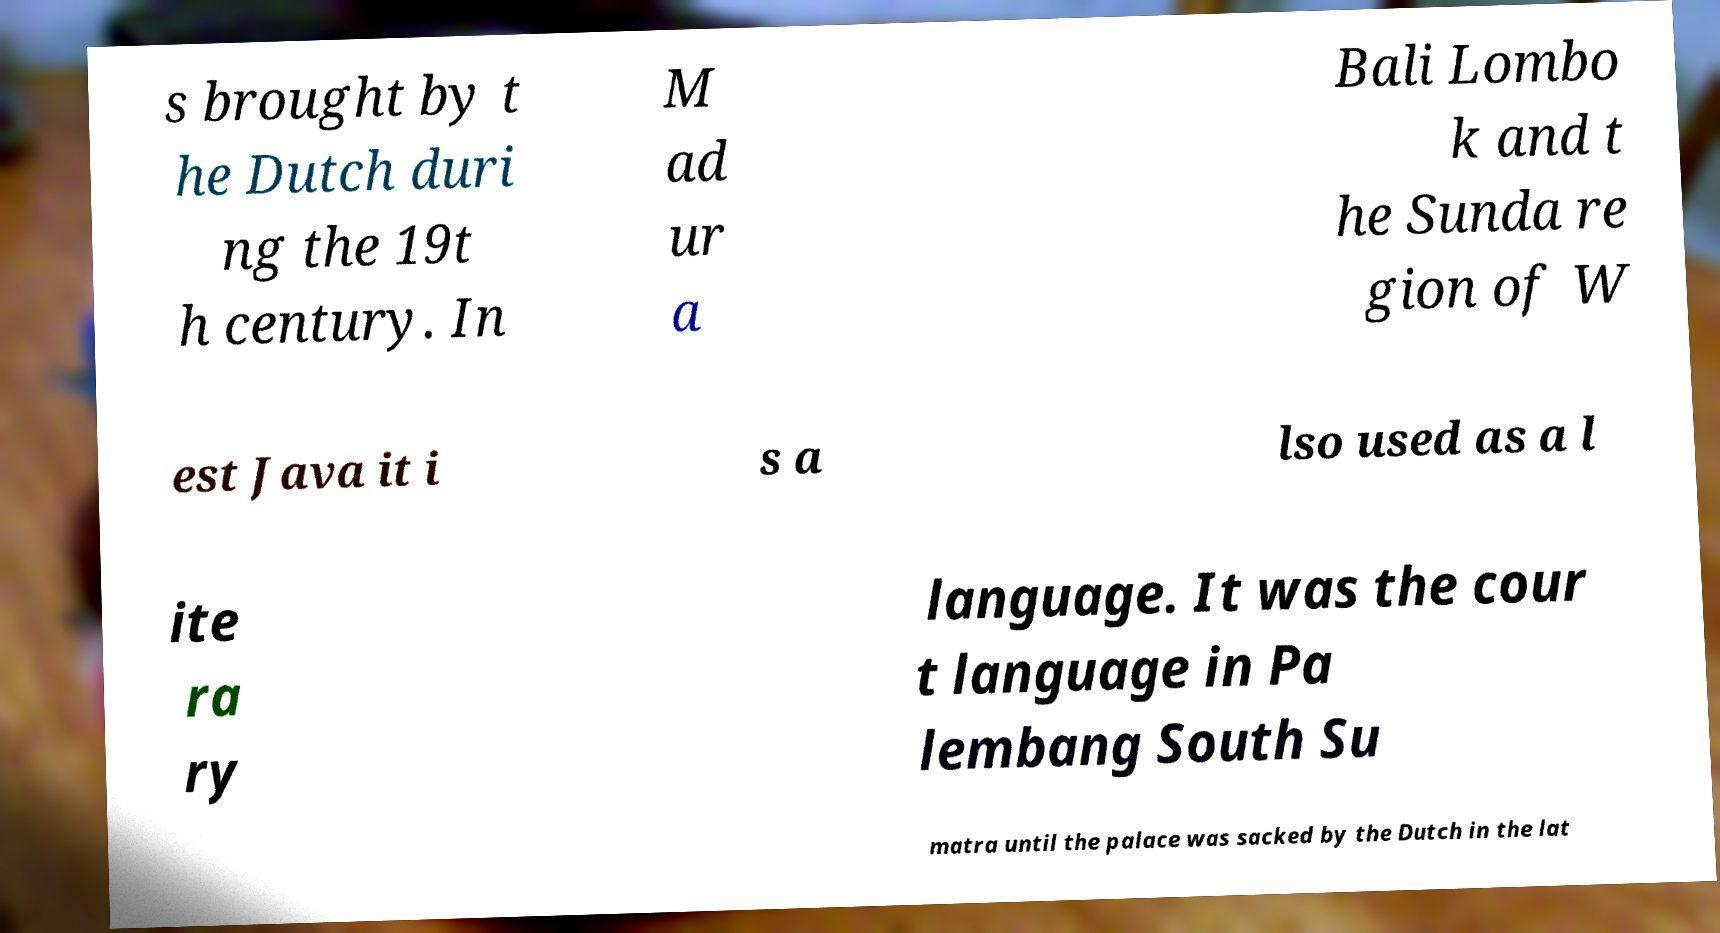Could you assist in decoding the text presented in this image and type it out clearly? s brought by t he Dutch duri ng the 19t h century. In M ad ur a Bali Lombo k and t he Sunda re gion of W est Java it i s a lso used as a l ite ra ry language. It was the cour t language in Pa lembang South Su matra until the palace was sacked by the Dutch in the lat 